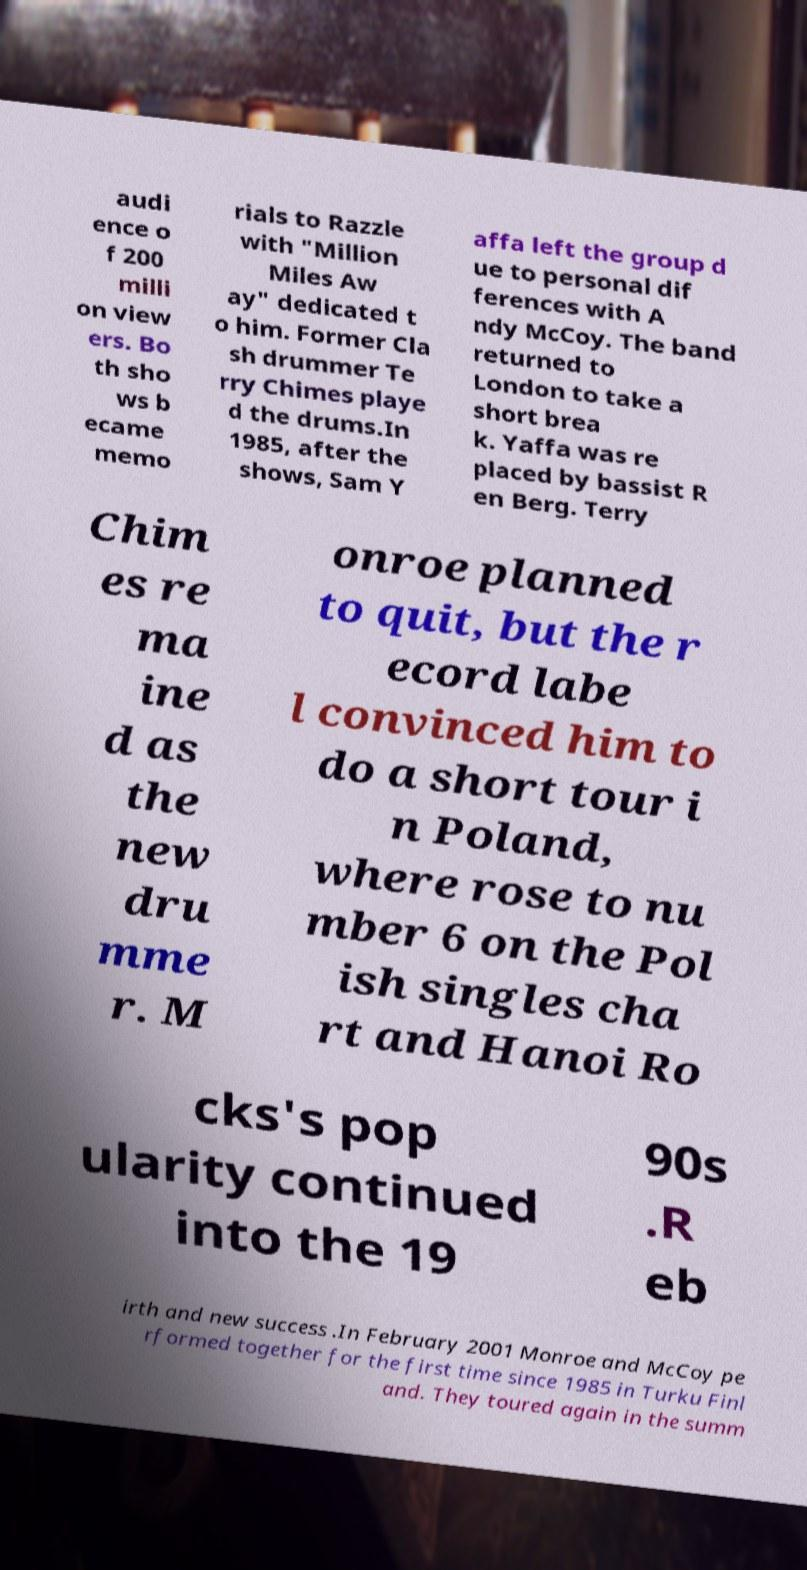I need the written content from this picture converted into text. Can you do that? audi ence o f 200 milli on view ers. Bo th sho ws b ecame memo rials to Razzle with "Million Miles Aw ay" dedicated t o him. Former Cla sh drummer Te rry Chimes playe d the drums.In 1985, after the shows, Sam Y affa left the group d ue to personal dif ferences with A ndy McCoy. The band returned to London to take a short brea k. Yaffa was re placed by bassist R en Berg. Terry Chim es re ma ine d as the new dru mme r. M onroe planned to quit, but the r ecord labe l convinced him to do a short tour i n Poland, where rose to nu mber 6 on the Pol ish singles cha rt and Hanoi Ro cks's pop ularity continued into the 19 90s .R eb irth and new success .In February 2001 Monroe and McCoy pe rformed together for the first time since 1985 in Turku Finl and. They toured again in the summ 